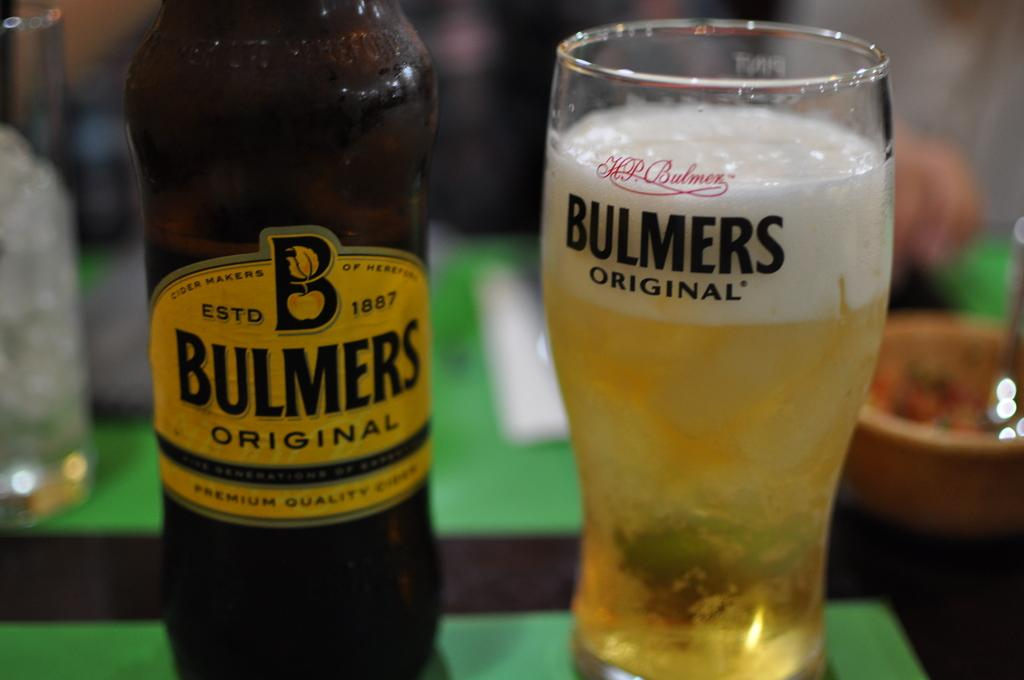<image>
Share a concise interpretation of the image provided. a glass and bottle of Bulmers Original Estd 1887 